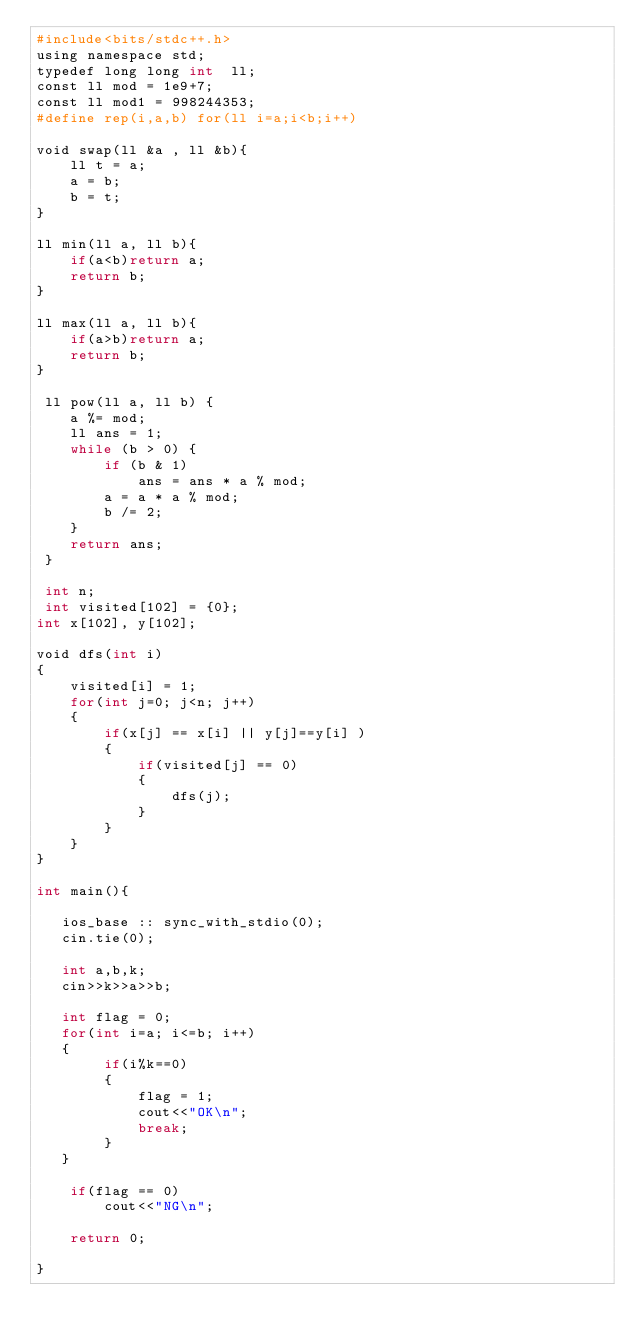Convert code to text. <code><loc_0><loc_0><loc_500><loc_500><_Awk_>#include<bits/stdc++.h>
using namespace std;
typedef long long int  ll;
const ll mod = 1e9+7;
const ll mod1 = 998244353;
#define rep(i,a,b) for(ll i=a;i<b;i++)

void swap(ll &a , ll &b){
    ll t = a;
    a = b;
    b = t;
}

ll min(ll a, ll b){
    if(a<b)return a;
    return b;
}

ll max(ll a, ll b){
    if(a>b)return a;
    return b;
}

 ll pow(ll a, ll b) {
    a %= mod;
    ll ans = 1;
    while (b > 0) {
        if (b & 1)
            ans = ans * a % mod;
        a = a * a % mod;
        b /= 2;
    }
    return ans;
 }

 int n;
 int visited[102] = {0};
int x[102], y[102];

void dfs(int i)
{
    visited[i] = 1;
    for(int j=0; j<n; j++)
    {
        if(x[j] == x[i] || y[j]==y[i] )
        {
            if(visited[j] == 0)
            {
                dfs(j);
            }
        }
    }
}

int main(){

   ios_base :: sync_with_stdio(0);
   cin.tie(0);

   int a,b,k;
   cin>>k>>a>>b;

   int flag = 0;
   for(int i=a; i<=b; i++)
   {
        if(i%k==0)
        {
            flag = 1;
            cout<<"OK\n";
            break;
        }
   }

    if(flag == 0)
        cout<<"NG\n";

    return 0;

}
</code> 